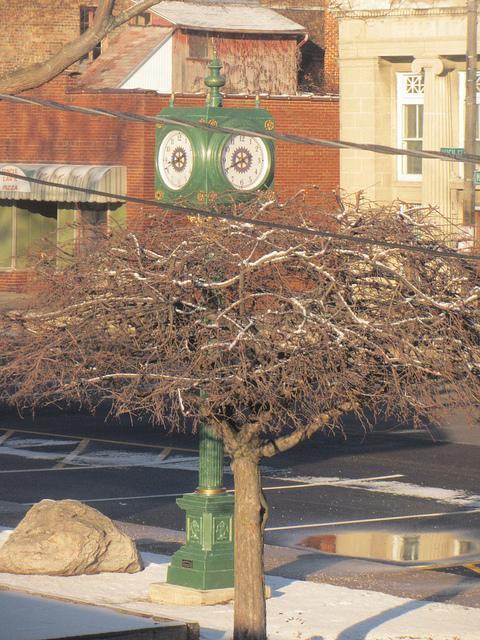How many hands does the clock have?
Give a very brief answer. 2. 